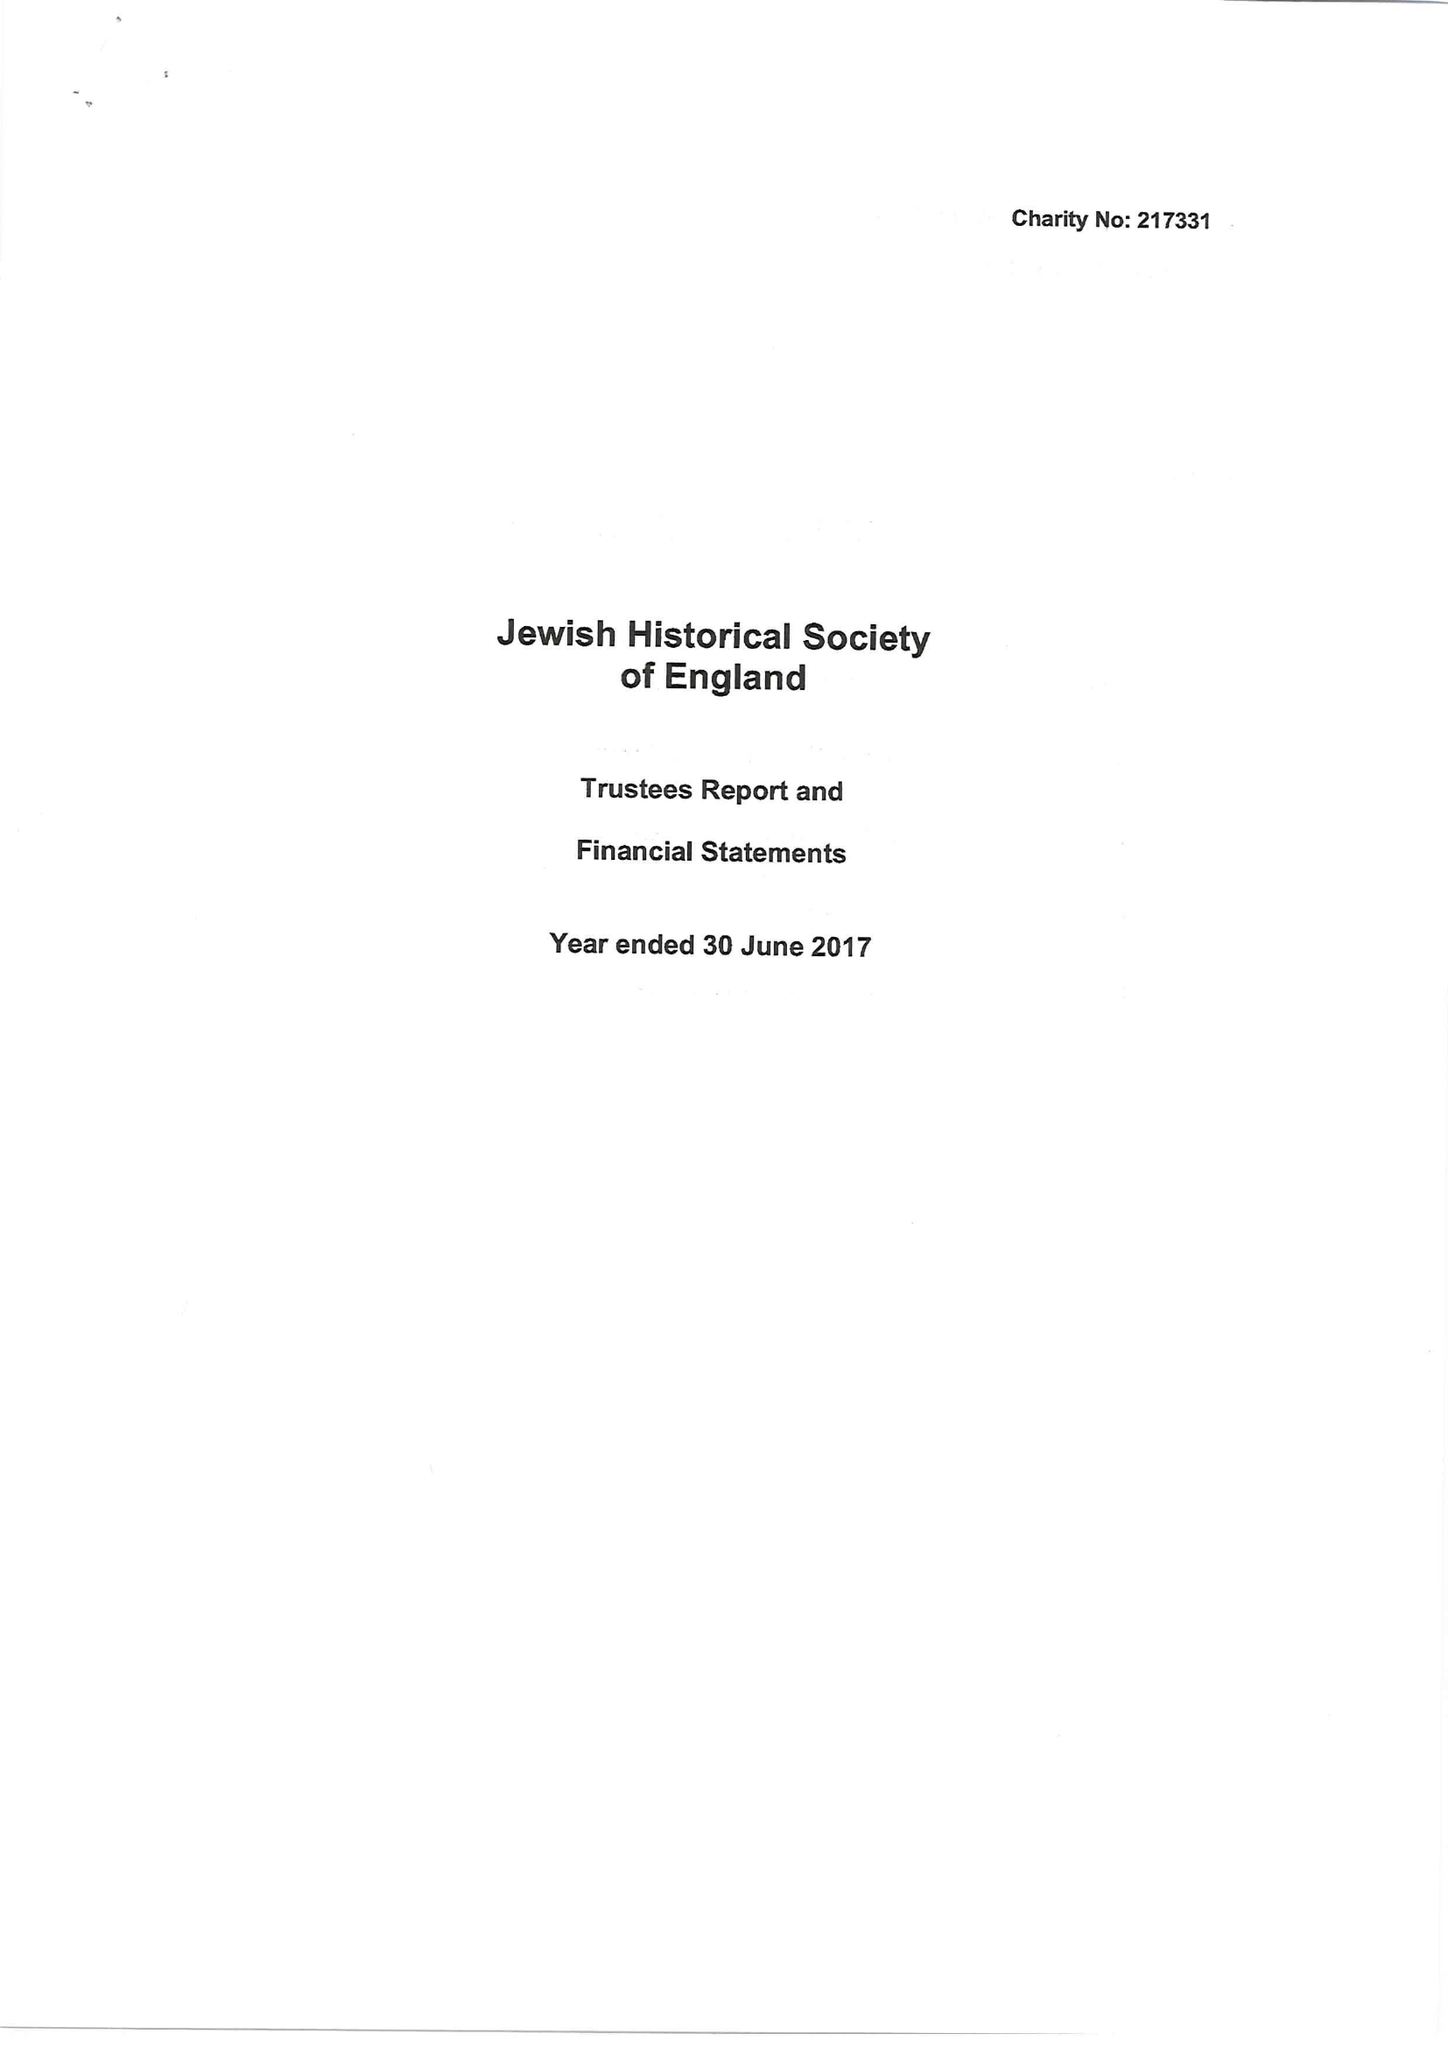What is the value for the charity_number?
Answer the question using a single word or phrase. 217331 